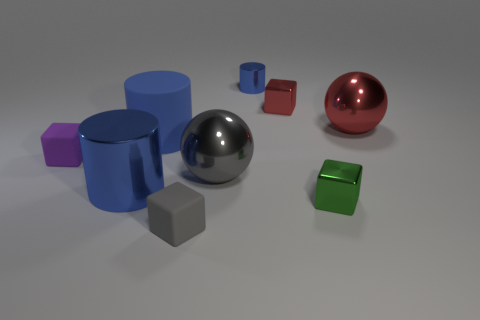How many other things are the same size as the purple matte thing?
Make the answer very short. 4. There is a metallic thing left of the gray metallic sphere; does it have the same shape as the small rubber thing that is behind the tiny gray matte block?
Offer a very short reply. No. How many things are either purple blocks or blue metal things in front of the small red metal thing?
Offer a terse response. 2. There is a blue thing that is behind the tiny purple cube and in front of the tiny red block; what material is it made of?
Offer a very short reply. Rubber. Is there any other thing that is the same shape as the large rubber object?
Ensure brevity in your answer.  Yes. What color is the tiny thing that is made of the same material as the small gray cube?
Give a very brief answer. Purple. How many things are either small cylinders or small green spheres?
Provide a succinct answer. 1. Is the size of the blue rubber thing the same as the shiny cylinder that is left of the tiny blue shiny cylinder?
Provide a succinct answer. Yes. The metallic cube behind the large red metallic object that is on the right side of the sphere in front of the large red shiny thing is what color?
Ensure brevity in your answer.  Red. What is the color of the matte cylinder?
Ensure brevity in your answer.  Blue. 